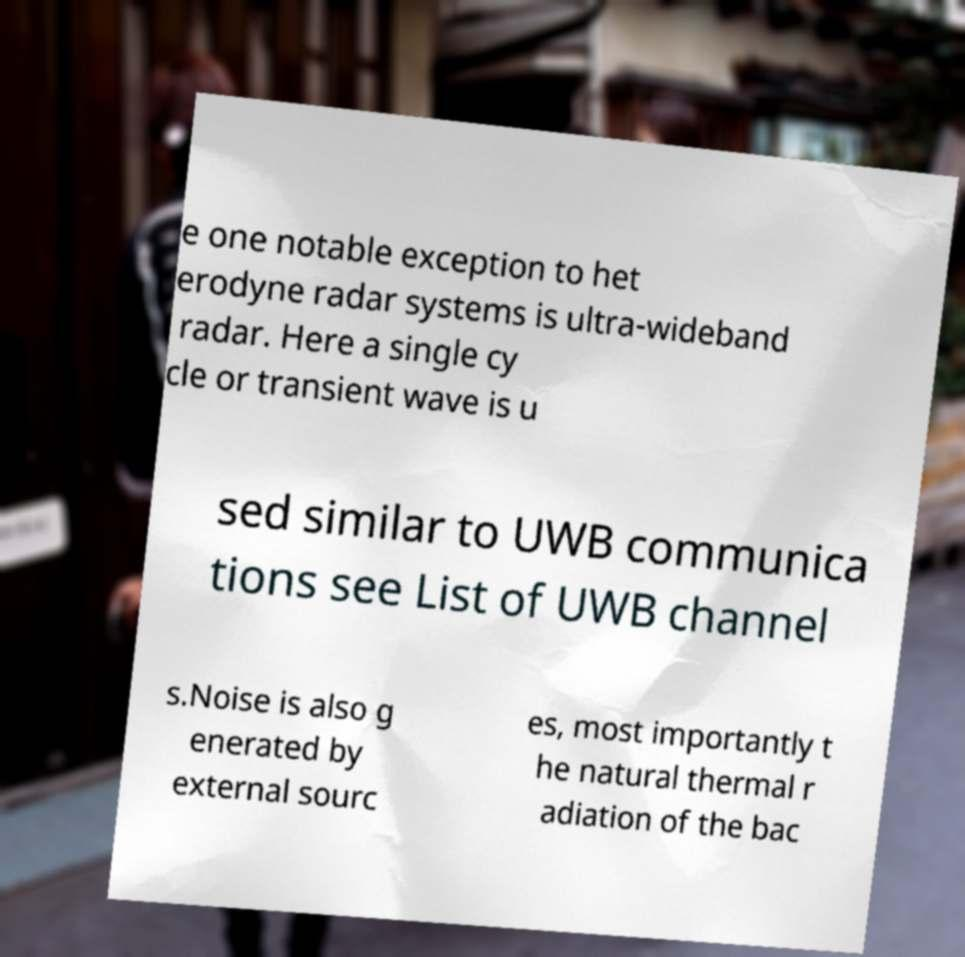Can you accurately transcribe the text from the provided image for me? e one notable exception to het erodyne radar systems is ultra-wideband radar. Here a single cy cle or transient wave is u sed similar to UWB communica tions see List of UWB channel s.Noise is also g enerated by external sourc es, most importantly t he natural thermal r adiation of the bac 